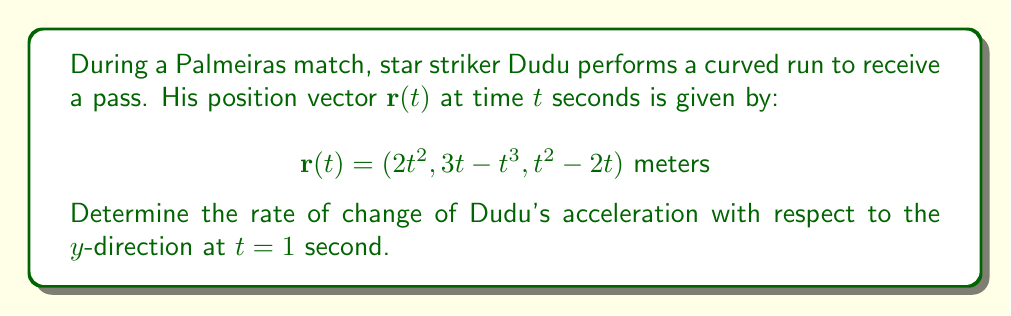Teach me how to tackle this problem. To solve this problem, we'll follow these steps:

1) First, we need to find the velocity vector $\mathbf{v}(t)$ by differentiating $\mathbf{r}(t)$ with respect to time:

   $$\mathbf{v}(t) = \frac{d\mathbf{r}}{dt} = (4t, 3-3t^2, 2t-2) \text{ m/s}$$

2) Next, we find the acceleration vector $\mathbf{a}(t)$ by differentiating $\mathbf{v}(t)$:

   $$\mathbf{a}(t) = \frac{d\mathbf{v}}{dt} = (4, -6t, 2) \text{ m/s}^2$$

3) The question asks for the rate of change of acceleration with respect to the $y$-direction. This means we need to find $\frac{\partial a_y}{\partial t}$, where $a_y$ is the $y$-component of $\mathbf{a}(t)$.

4) From $\mathbf{a}(t)$, we can see that $a_y = -6t$.

5) Now we differentiate $a_y$ with respect to time:

   $$\frac{\partial a_y}{\partial t} = -6 \text{ m/s}^3$$

6) The question asks for this value at $t=1$ second. However, we can see that $\frac{\partial a_y}{\partial t}$ is constant and doesn't depend on $t$, so its value is always $-6 \text{ m/s}^3$.
Answer: $-6 \text{ m/s}^3$ 